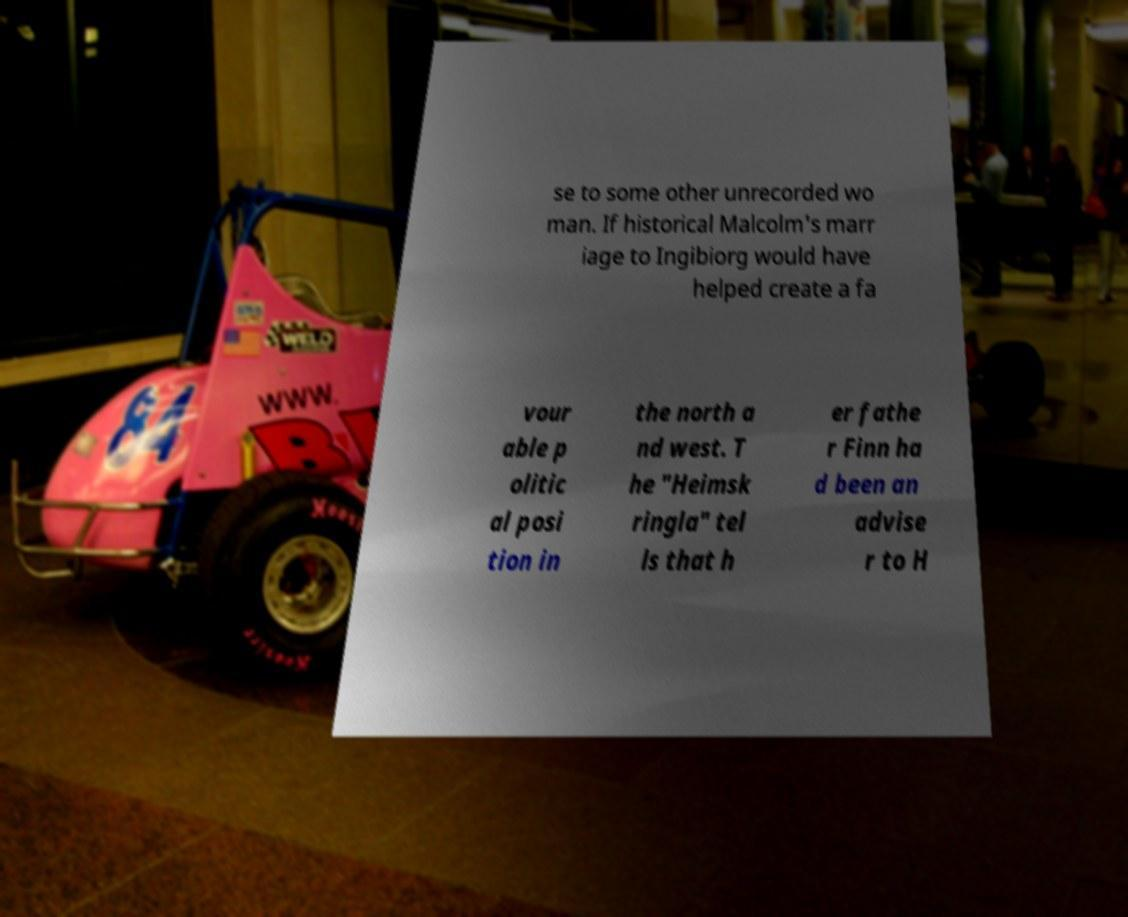There's text embedded in this image that I need extracted. Can you transcribe it verbatim? se to some other unrecorded wo man. If historical Malcolm's marr iage to Ingibiorg would have helped create a fa vour able p olitic al posi tion in the north a nd west. T he "Heimsk ringla" tel ls that h er fathe r Finn ha d been an advise r to H 